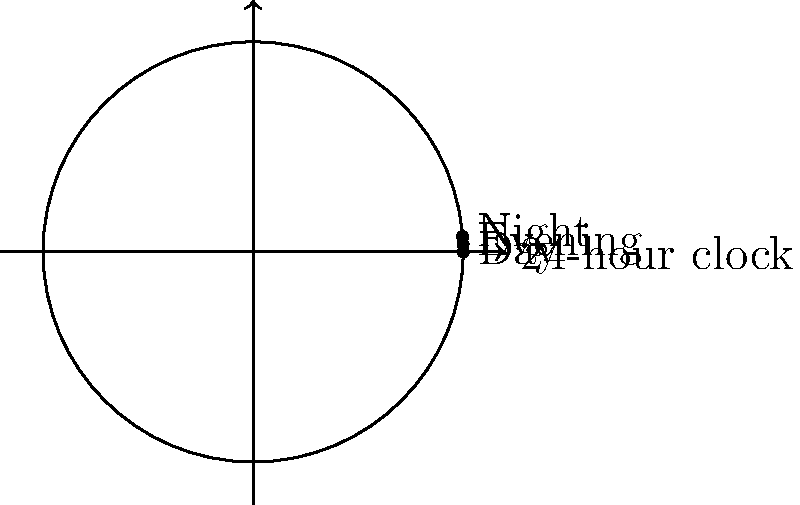In a hospital, nurses work in three 8-hour shifts: Day (0-8), Evening (8-16), and Night (16-24). This shift schedule forms a cyclic group under rotation. If a nurse starts with a Day shift, how many rotations are needed to return to a Day shift, and what is the order of this cyclic group? To solve this problem, let's follow these steps:

1. Understand the group structure:
   - The shifts form a cyclic group under rotation.
   - Each rotation moves the shift forward by 8 hours.

2. Analyze the rotations:
   - Starting from Day (0-8):
     - 1 rotation: Evening (8-16)
     - 2 rotations: Night (16-24)
     - 3 rotations: Day (0-8)

3. Determine the number of rotations to return to the starting position:
   - It takes 3 rotations to return to the Day shift.

4. Identify the order of the cyclic group:
   - The order of a cyclic group is the smallest positive integer $n$ such that $g^n = e$, where $g$ is the generator and $e$ is the identity element.
   - In this case, the number of rotations to return to the starting position is the order of the group.

5. Conclude:
   - The number of rotations needed to return to a Day shift is 3.
   - The order of this cyclic group is also 3.

In group theory notation, this cyclic group can be represented as $C_3$ or $\mathbb{Z}_3$.
Answer: 3 rotations; order 3 ($C_3$ or $\mathbb{Z}_3$) 